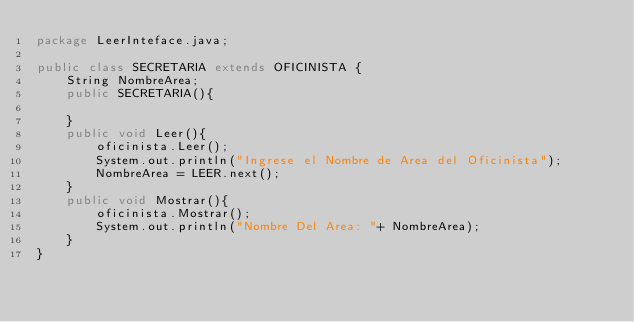Convert code to text. <code><loc_0><loc_0><loc_500><loc_500><_Java_>package LeerInteface.java;

public class SECRETARIA extends OFICINISTA {
    String NombreArea;
    public SECRETARIA(){

    }
    public void Leer(){
        oficinista.Leer();
        System.out.println("Ingrese el Nombre de Area del Oficinista");
        NombreArea = LEER.next();
    }
    public void Mostrar(){
        oficinista.Mostrar();
        System.out.println("Nombre Del Area: "+ NombreArea);
    }
}
</code> 